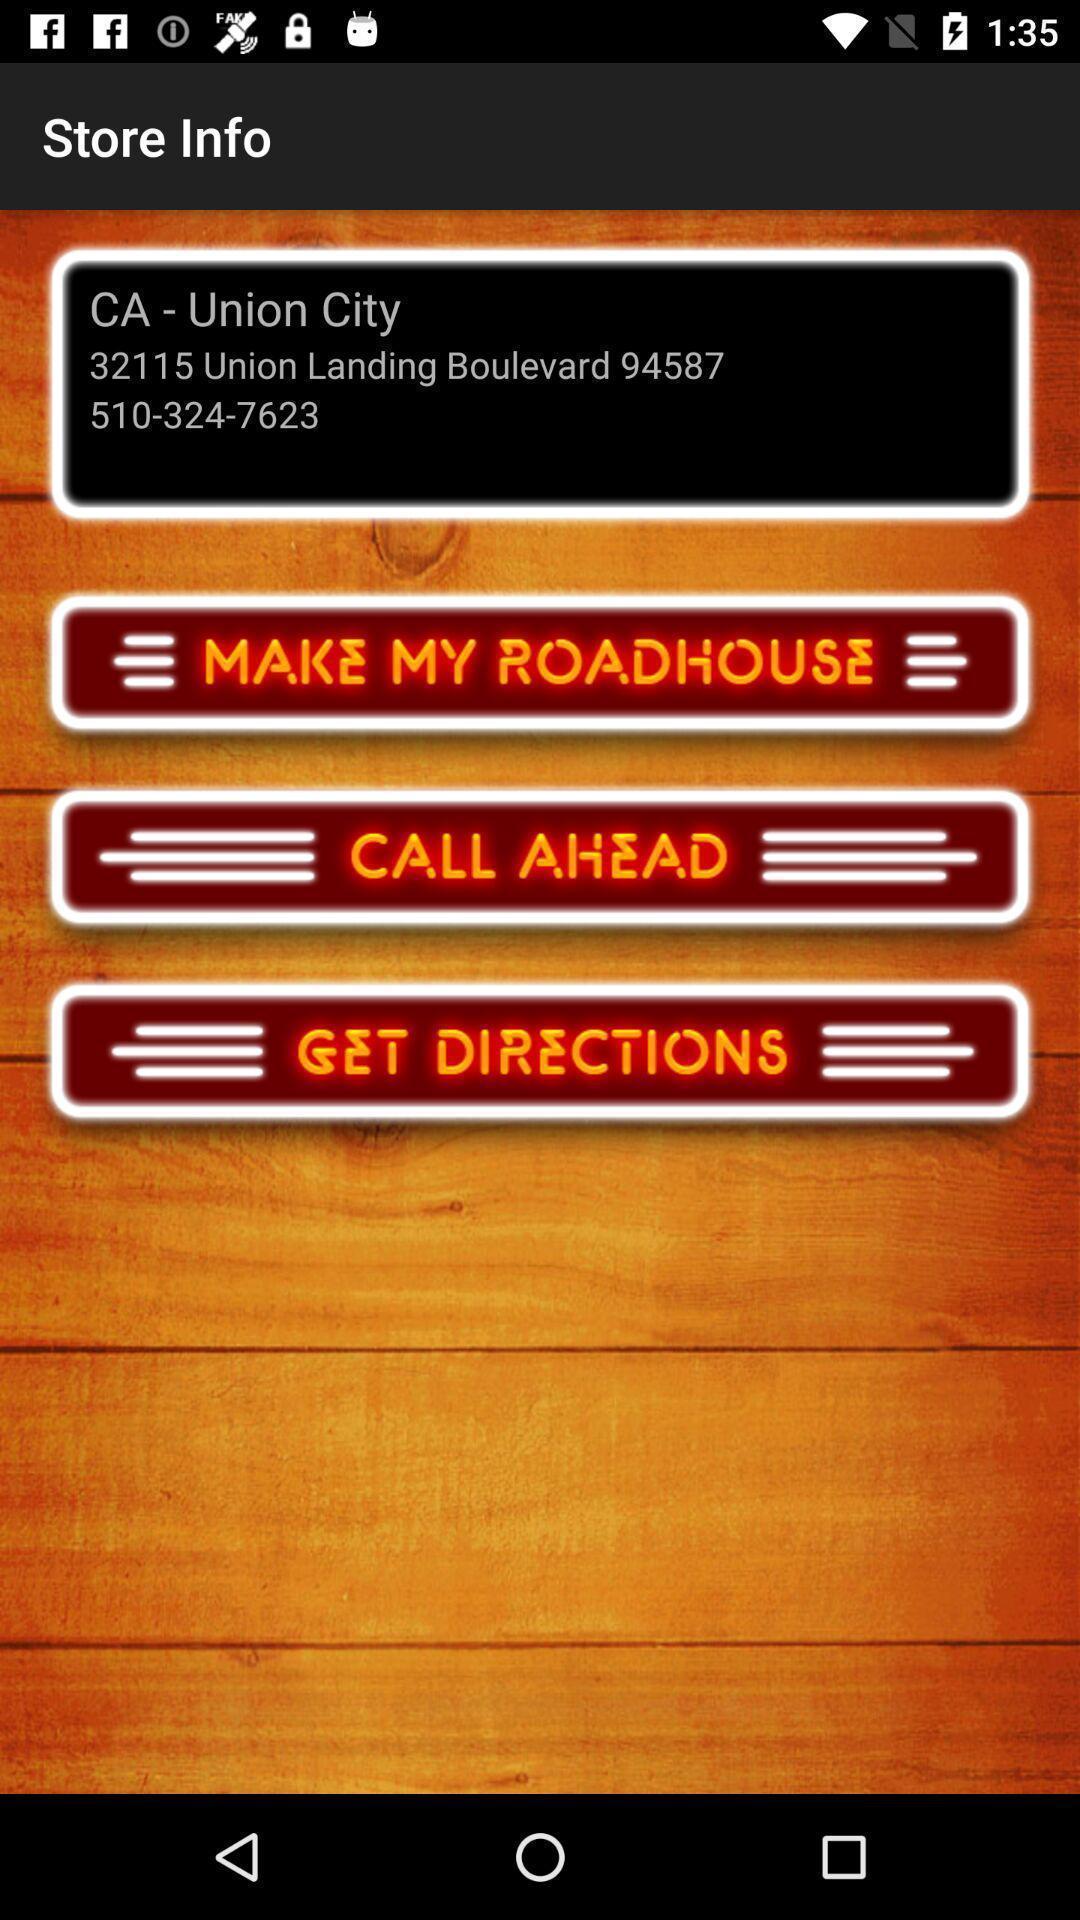Explain what's happening in this screen capture. Screen showing store info. 